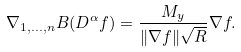Convert formula to latex. <formula><loc_0><loc_0><loc_500><loc_500>\nabla _ { 1 , \dots , n } B ( D ^ { \alpha } { f } ) = \frac { M _ { y } } { \| \nabla f \| \sqrt { R } } \nabla f .</formula> 